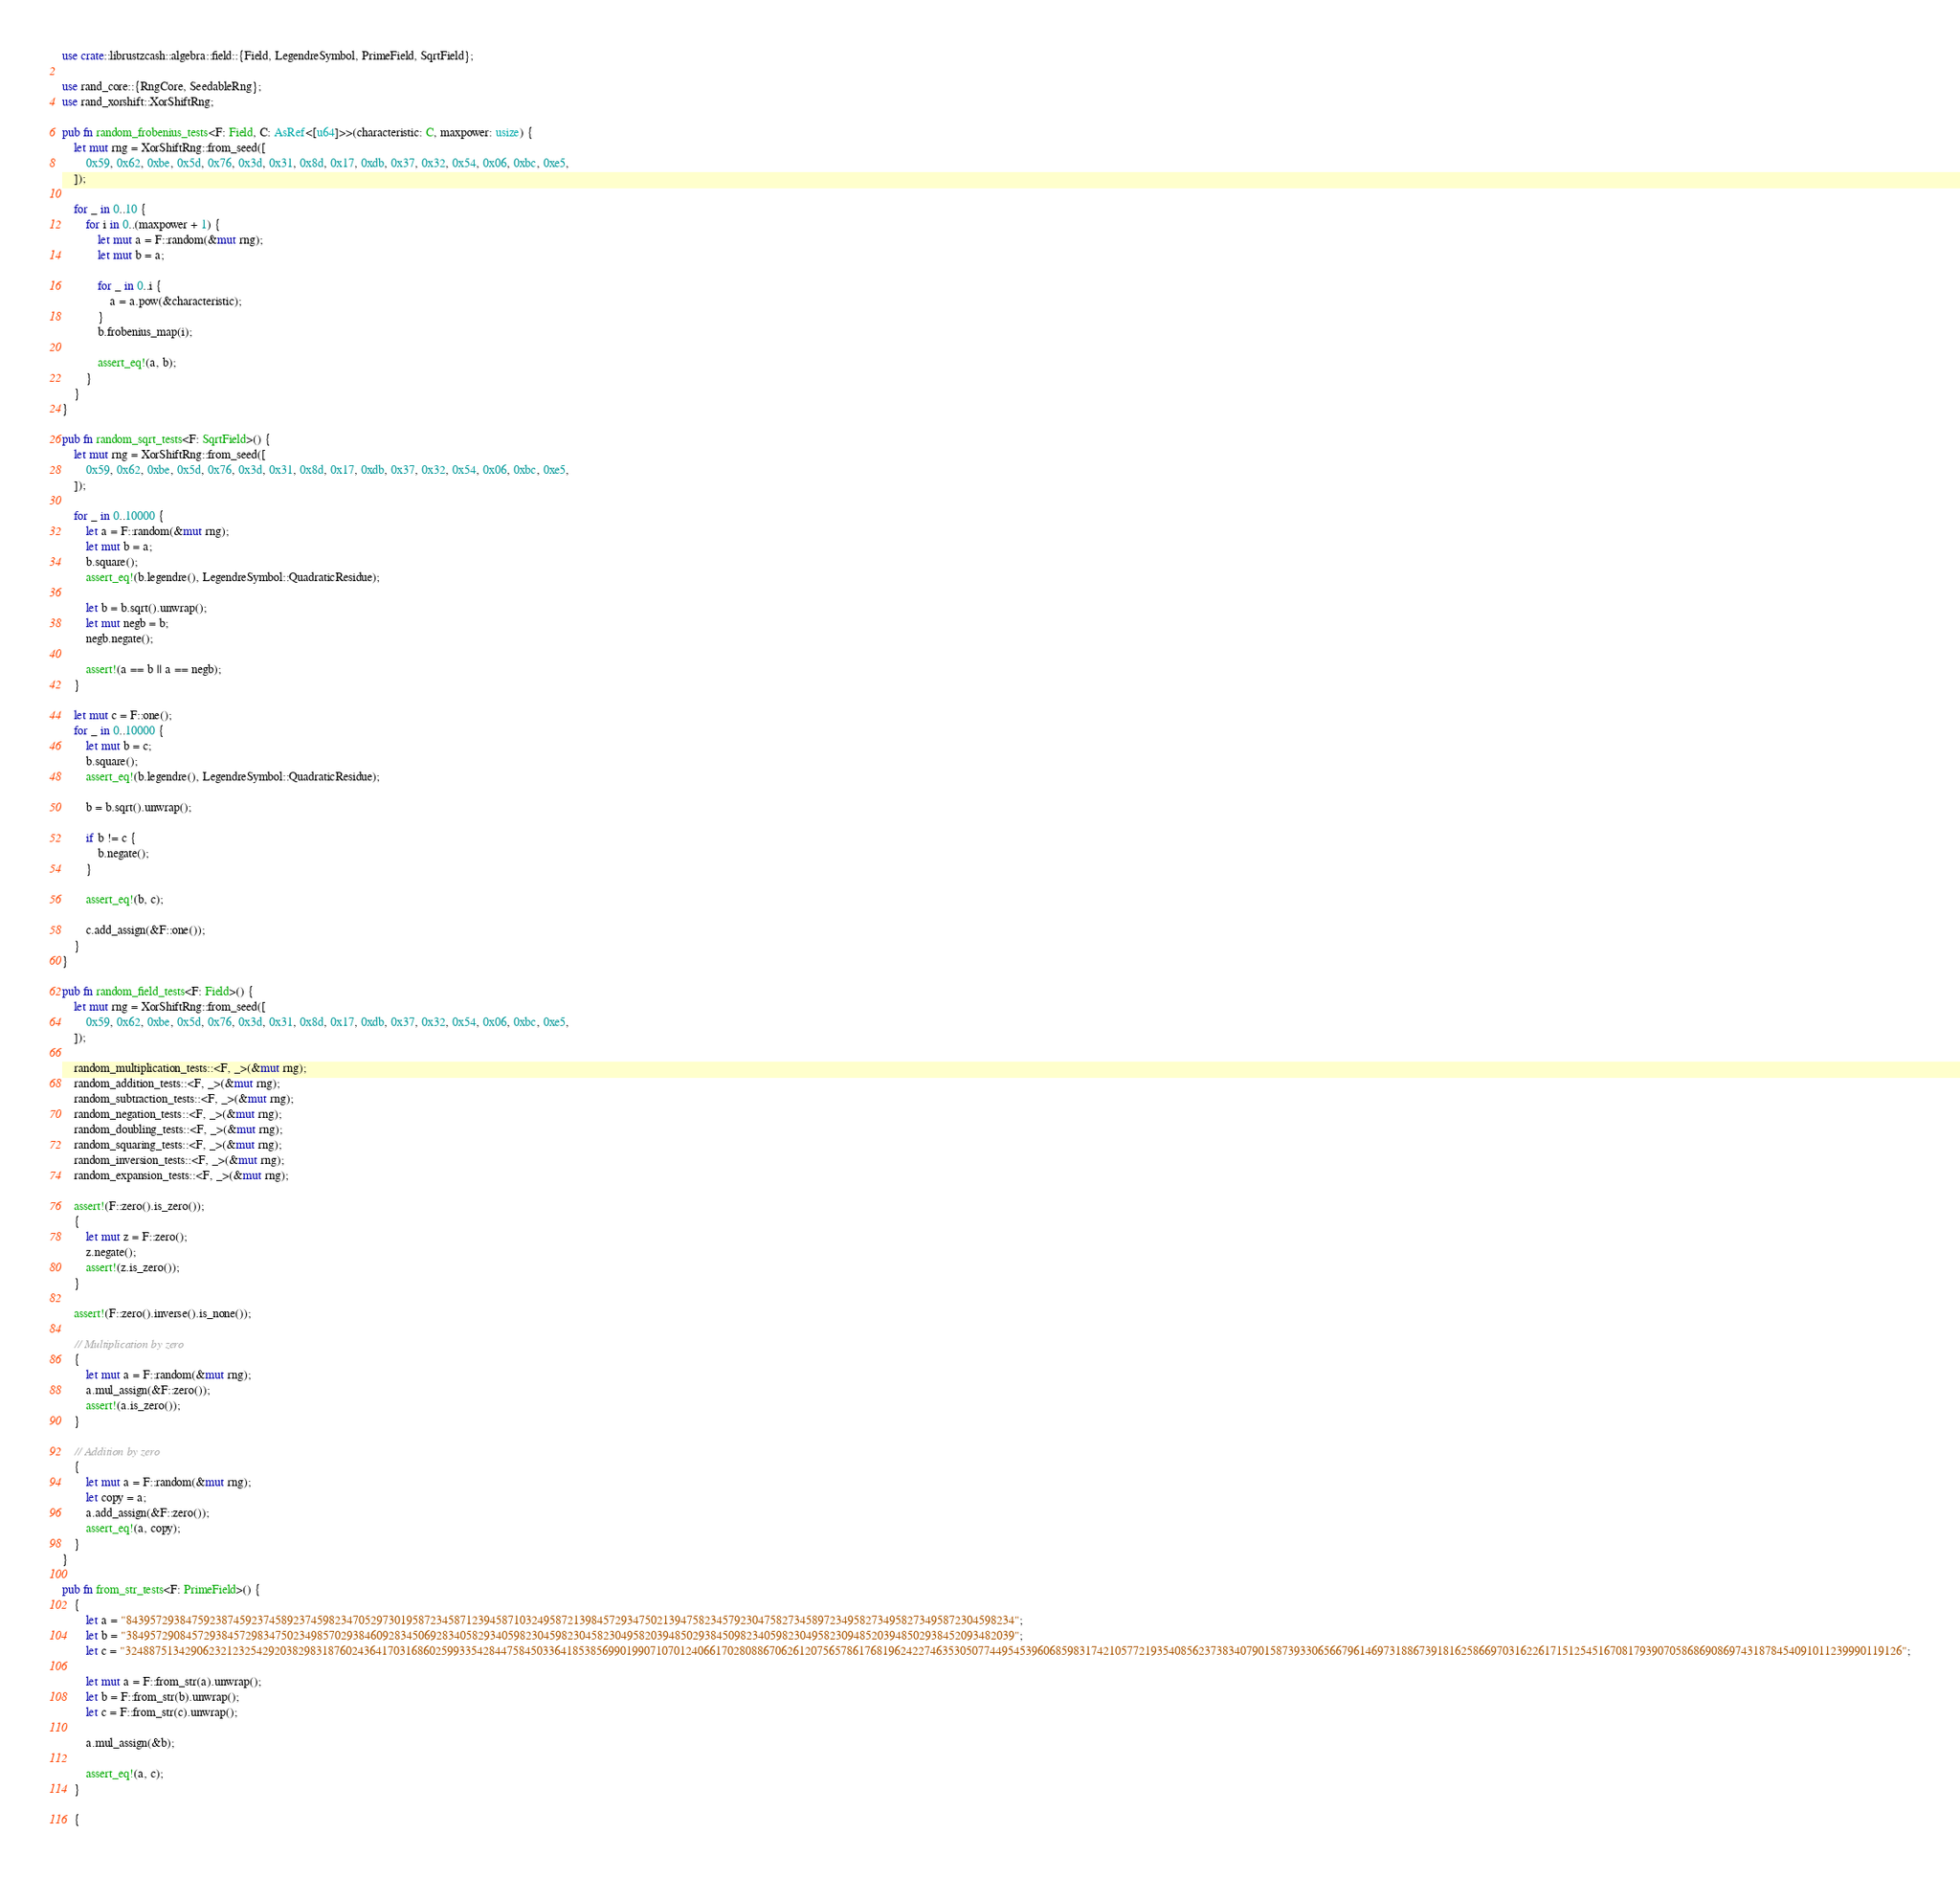Convert code to text. <code><loc_0><loc_0><loc_500><loc_500><_Rust_>use crate::librustzcash::algebra::field::{Field, LegendreSymbol, PrimeField, SqrtField};

use rand_core::{RngCore, SeedableRng};
use rand_xorshift::XorShiftRng;

pub fn random_frobenius_tests<F: Field, C: AsRef<[u64]>>(characteristic: C, maxpower: usize) {
    let mut rng = XorShiftRng::from_seed([
        0x59, 0x62, 0xbe, 0x5d, 0x76, 0x3d, 0x31, 0x8d, 0x17, 0xdb, 0x37, 0x32, 0x54, 0x06, 0xbc, 0xe5,
    ]);

    for _ in 0..10 {
        for i in 0..(maxpower + 1) {
            let mut a = F::random(&mut rng);
            let mut b = a;

            for _ in 0..i {
                a = a.pow(&characteristic);
            }
            b.frobenius_map(i);

            assert_eq!(a, b);
        }
    }
}

pub fn random_sqrt_tests<F: SqrtField>() {
    let mut rng = XorShiftRng::from_seed([
        0x59, 0x62, 0xbe, 0x5d, 0x76, 0x3d, 0x31, 0x8d, 0x17, 0xdb, 0x37, 0x32, 0x54, 0x06, 0xbc, 0xe5,
    ]);

    for _ in 0..10000 {
        let a = F::random(&mut rng);
        let mut b = a;
        b.square();
        assert_eq!(b.legendre(), LegendreSymbol::QuadraticResidue);

        let b = b.sqrt().unwrap();
        let mut negb = b;
        negb.negate();

        assert!(a == b || a == negb);
    }

    let mut c = F::one();
    for _ in 0..10000 {
        let mut b = c;
        b.square();
        assert_eq!(b.legendre(), LegendreSymbol::QuadraticResidue);

        b = b.sqrt().unwrap();

        if b != c {
            b.negate();
        }

        assert_eq!(b, c);

        c.add_assign(&F::one());
    }
}

pub fn random_field_tests<F: Field>() {
    let mut rng = XorShiftRng::from_seed([
        0x59, 0x62, 0xbe, 0x5d, 0x76, 0x3d, 0x31, 0x8d, 0x17, 0xdb, 0x37, 0x32, 0x54, 0x06, 0xbc, 0xe5,
    ]);

    random_multiplication_tests::<F, _>(&mut rng);
    random_addition_tests::<F, _>(&mut rng);
    random_subtraction_tests::<F, _>(&mut rng);
    random_negation_tests::<F, _>(&mut rng);
    random_doubling_tests::<F, _>(&mut rng);
    random_squaring_tests::<F, _>(&mut rng);
    random_inversion_tests::<F, _>(&mut rng);
    random_expansion_tests::<F, _>(&mut rng);

    assert!(F::zero().is_zero());
    {
        let mut z = F::zero();
        z.negate();
        assert!(z.is_zero());
    }

    assert!(F::zero().inverse().is_none());

    // Multiplication by zero
    {
        let mut a = F::random(&mut rng);
        a.mul_assign(&F::zero());
        assert!(a.is_zero());
    }

    // Addition by zero
    {
        let mut a = F::random(&mut rng);
        let copy = a;
        a.add_assign(&F::zero());
        assert_eq!(a, copy);
    }
}

pub fn from_str_tests<F: PrimeField>() {
    {
        let a = "84395729384759238745923745892374598234705297301958723458712394587103249587213984572934750213947582345792304758273458972349582734958273495872304598234";
        let b = "38495729084572938457298347502349857029384609283450692834058293405982304598230458230495820394850293845098234059823049582309485203948502938452093482039";
        let c = "3248875134290623212325429203829831876024364170316860259933542844758450336418538569901990710701240661702808867062612075657861768196242274635305077449545396068598317421057721935408562373834079015873933065667961469731886739181625866970316226171512545167081793907058686908697431878454091011239990119126";

        let mut a = F::from_str(a).unwrap();
        let b = F::from_str(b).unwrap();
        let c = F::from_str(c).unwrap();

        a.mul_assign(&b);

        assert_eq!(a, c);
    }

    {</code> 